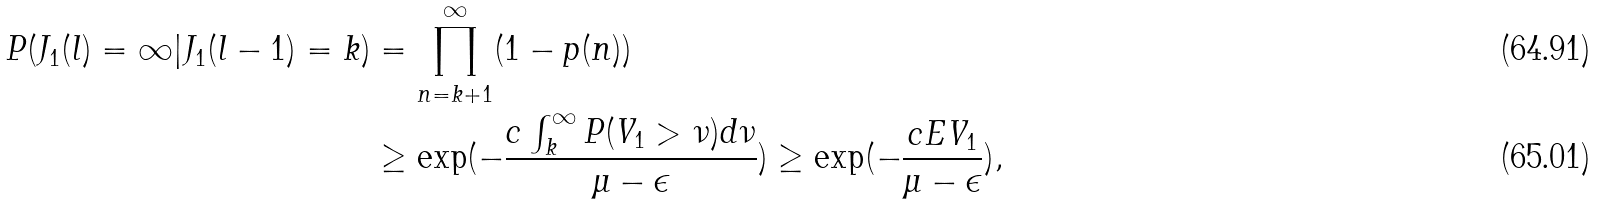<formula> <loc_0><loc_0><loc_500><loc_500>P ( J _ { 1 } ( l ) = \infty | J _ { 1 } ( l - 1 ) = k ) & = \prod _ { n = k + 1 } ^ { \infty } ( 1 - p ( n ) ) \\ & \geq \exp ( - \frac { c \int _ { k } ^ { \infty } P ( V _ { 1 } > \nu ) d \nu } { \mu - \epsilon } ) \geq \exp ( - \frac { c E V _ { 1 } } { \mu - \epsilon } ) ,</formula> 